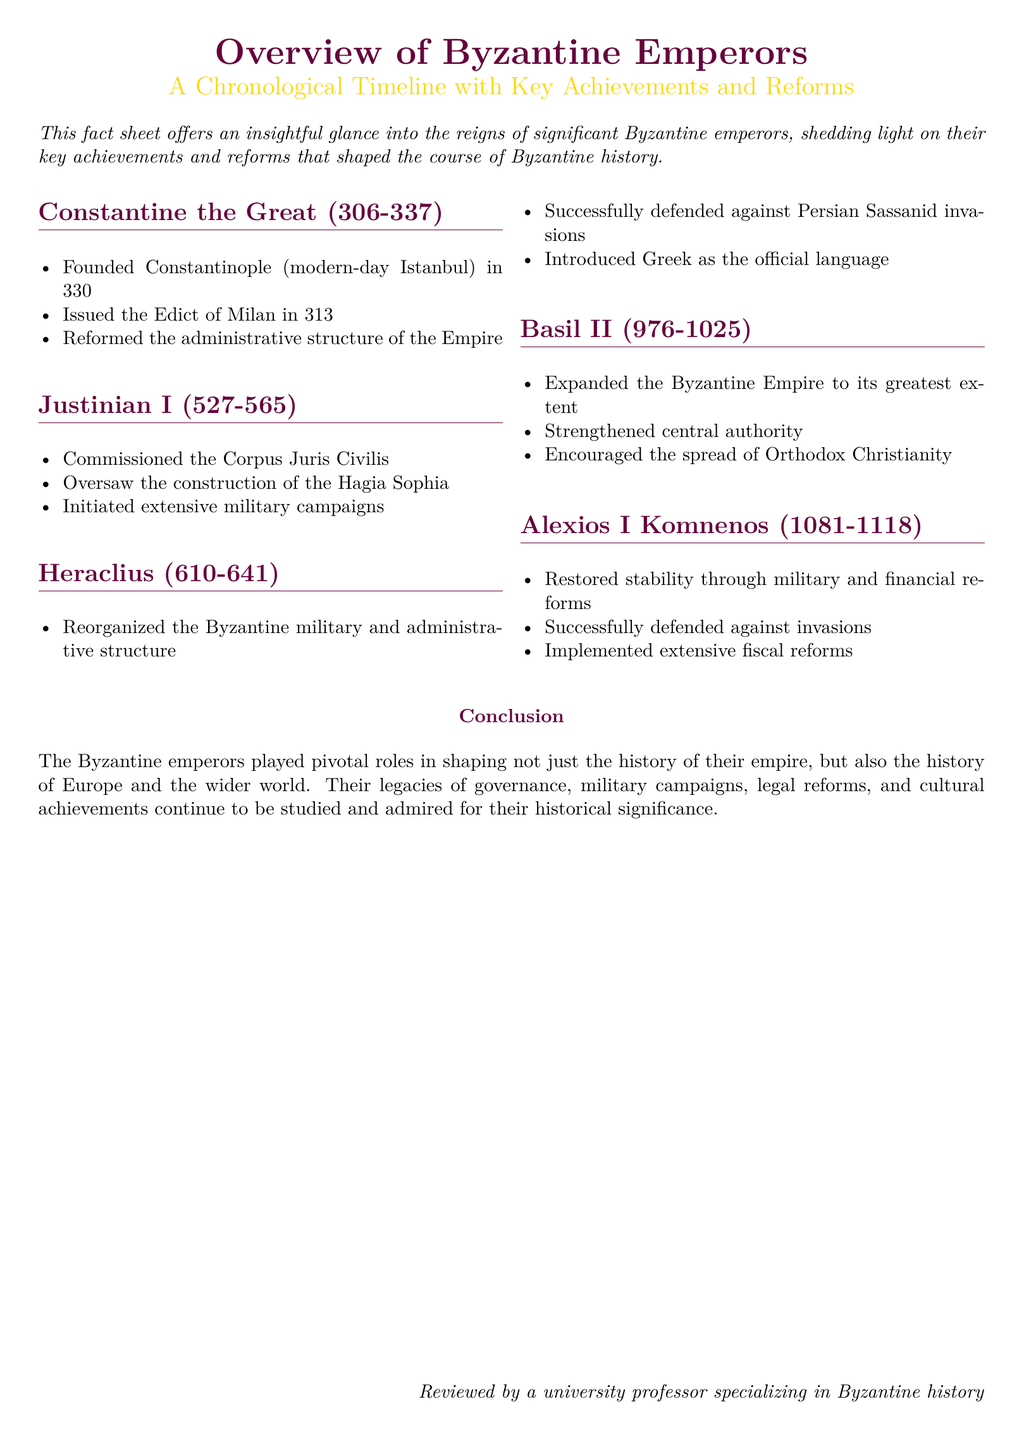What year was Constantinople founded? The document states that Constantinople was founded in the year 330.
Answer: 330 Who commissioned the Corpus Juris Civilis? The fact sheet mentions that Justinian I commissioned the Corpus Juris Civilis.
Answer: Justinian I What was introduced as the official language by Heraclius? The document indicates that Heraclius introduced Greek as the official language.
Answer: Greek Which emperor expanded the Byzantine Empire to its greatest extent? According to the fact sheet, Basil II expanded the Byzantine Empire to its greatest extent.
Answer: Basil II What significant structure was constructed during Justinian I's reign? The fact sheet highlights the construction of the Hagia Sophia during Justinian I's reign.
Answer: Hagia Sophia How long did Alexios I Komnenos rule? The document states that Alexios I Komnenos ruled from 1081 to 1118, which is a span of 37 years.
Answer: 37 years What key reform did Heraclius implement in the military? The fact sheet mentions that Heraclius reorganized the Byzantine military.
Answer: Reorganized Who is acknowledged for reviewing the document? The document notes that it was reviewed by a university professor specializing in Byzantine history.
Answer: A university professor What major military event did Basil II encourage? The document states that Basil II encouraged the spread of Orthodox Christianity, which is a military and cultural achievement.
Answer: Spread of Orthodox Christianity 